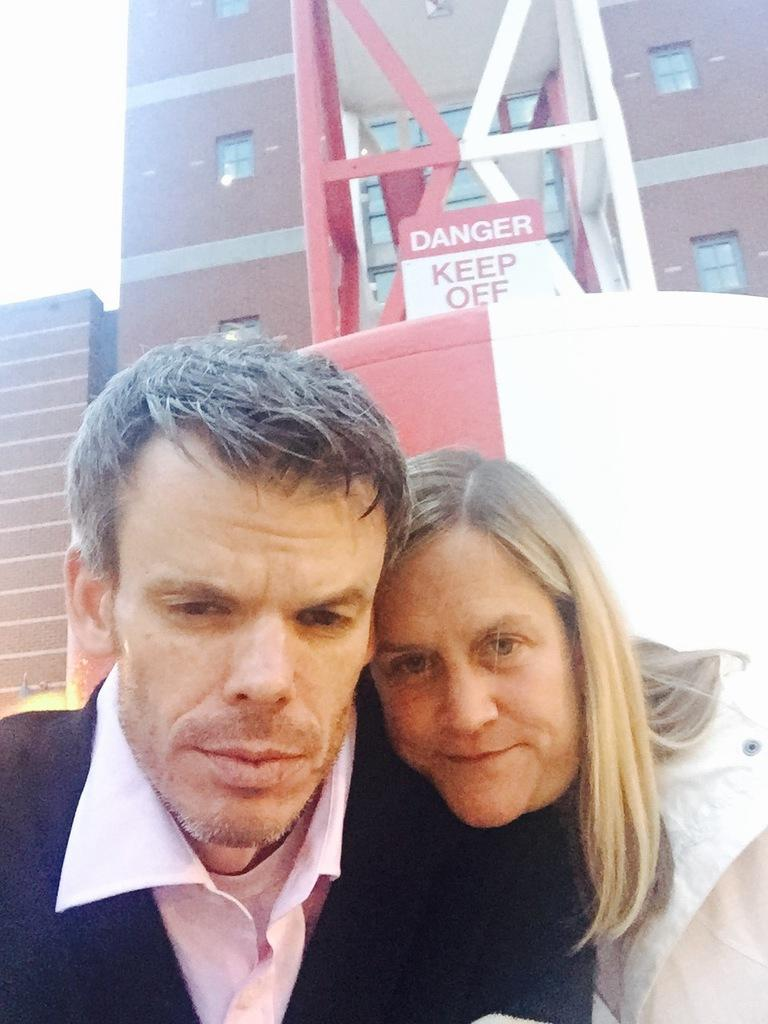How many people are present in the image? There is a man and a woman in the image. What can be seen in the background of the image? There is a building in the background of the image. What object is visible in the image? There is a board visible in the image. What type of statement can be seen written on the board in the image? There is no statement visible on the board in the image; it is not mentioned in the provided facts. How many rabbits are present in the image? There are no rabbits present in the image. 